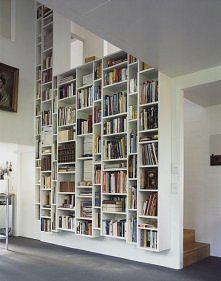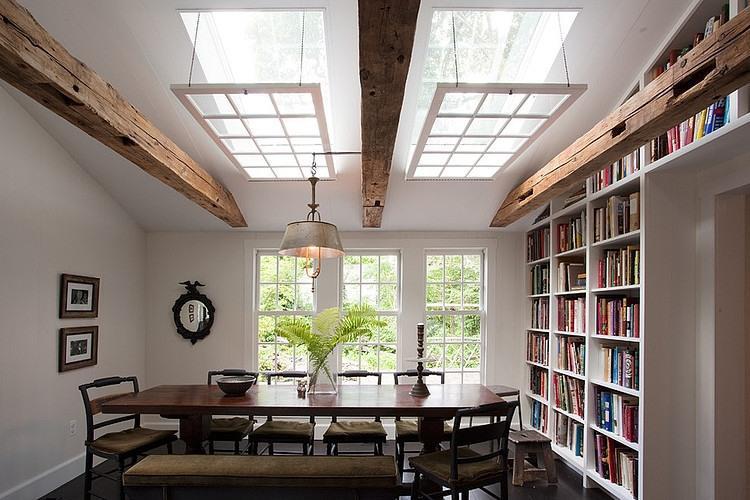The first image is the image on the left, the second image is the image on the right. Examine the images to the left and right. Is the description "the library is made of dark stained wood" accurate? Answer yes or no. No. 